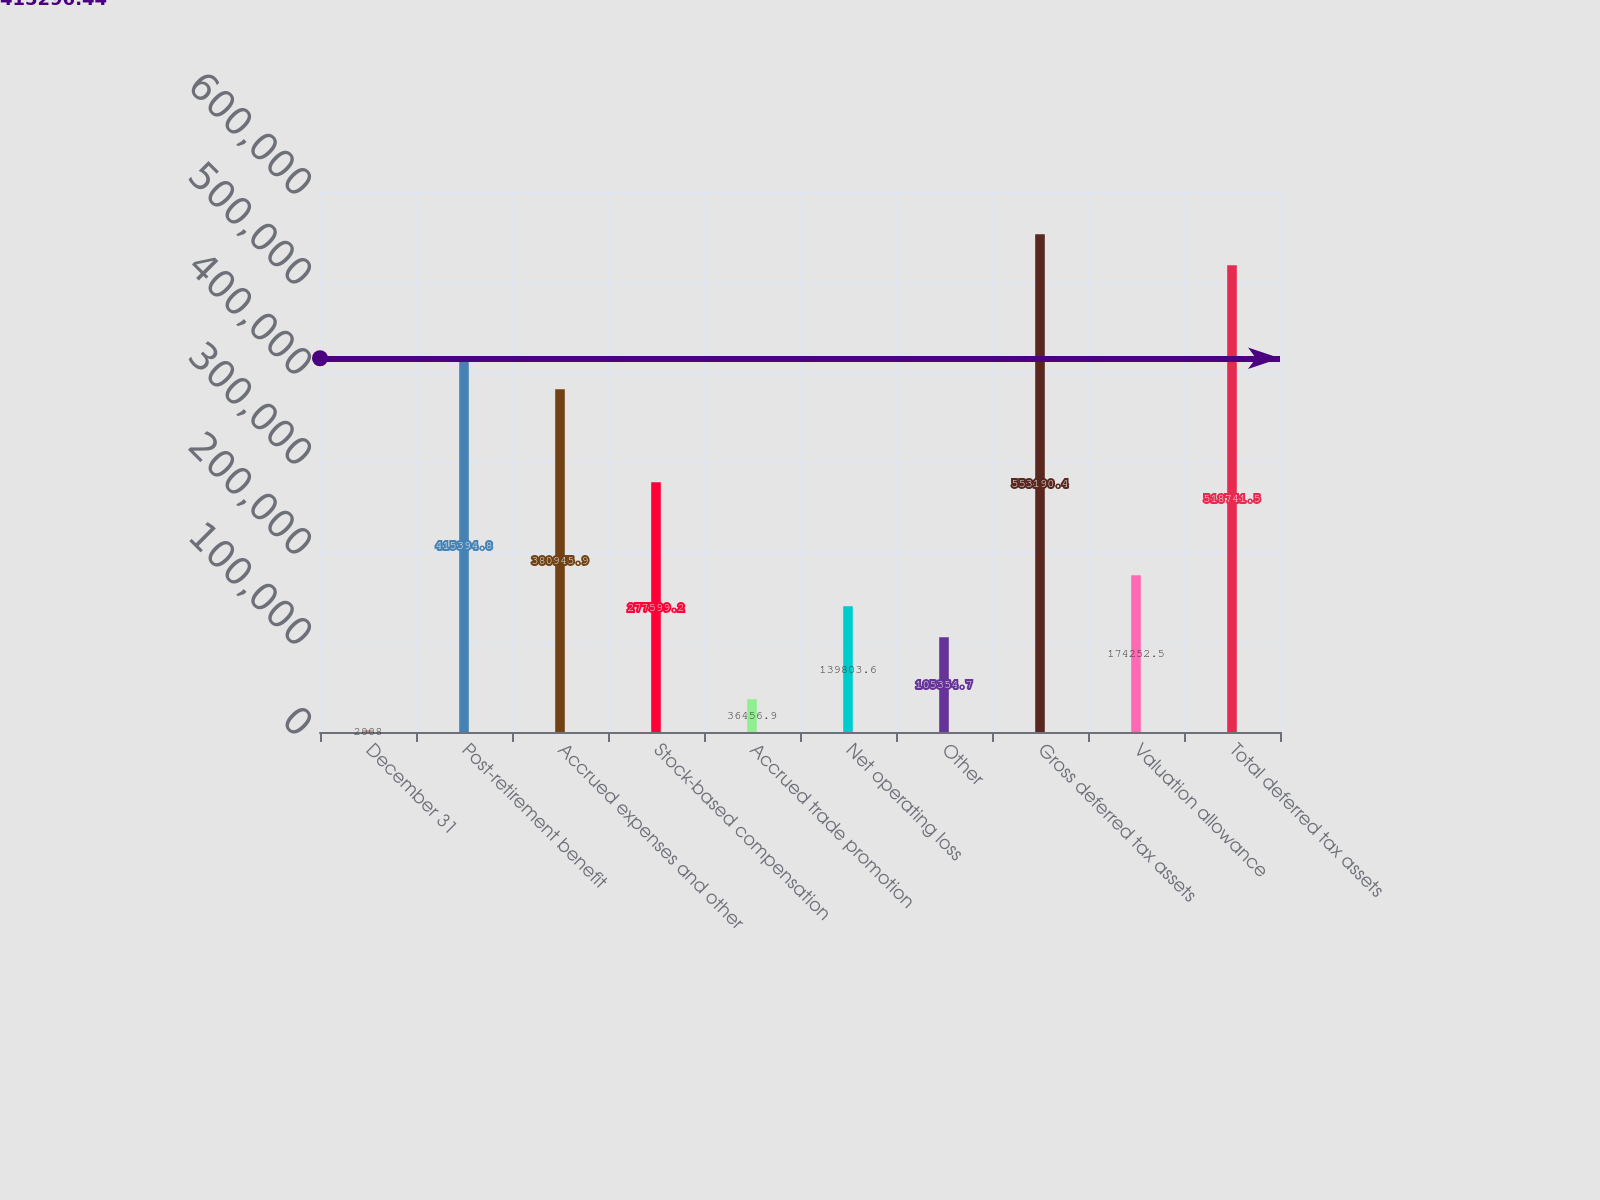Convert chart to OTSL. <chart><loc_0><loc_0><loc_500><loc_500><bar_chart><fcel>December 31<fcel>Post-retirement benefit<fcel>Accrued expenses and other<fcel>Stock-based compensation<fcel>Accrued trade promotion<fcel>Net operating loss<fcel>Other<fcel>Gross deferred tax assets<fcel>Valuation allowance<fcel>Total deferred tax assets<nl><fcel>2008<fcel>415395<fcel>380946<fcel>277599<fcel>36456.9<fcel>139804<fcel>105355<fcel>553190<fcel>174252<fcel>518742<nl></chart> 